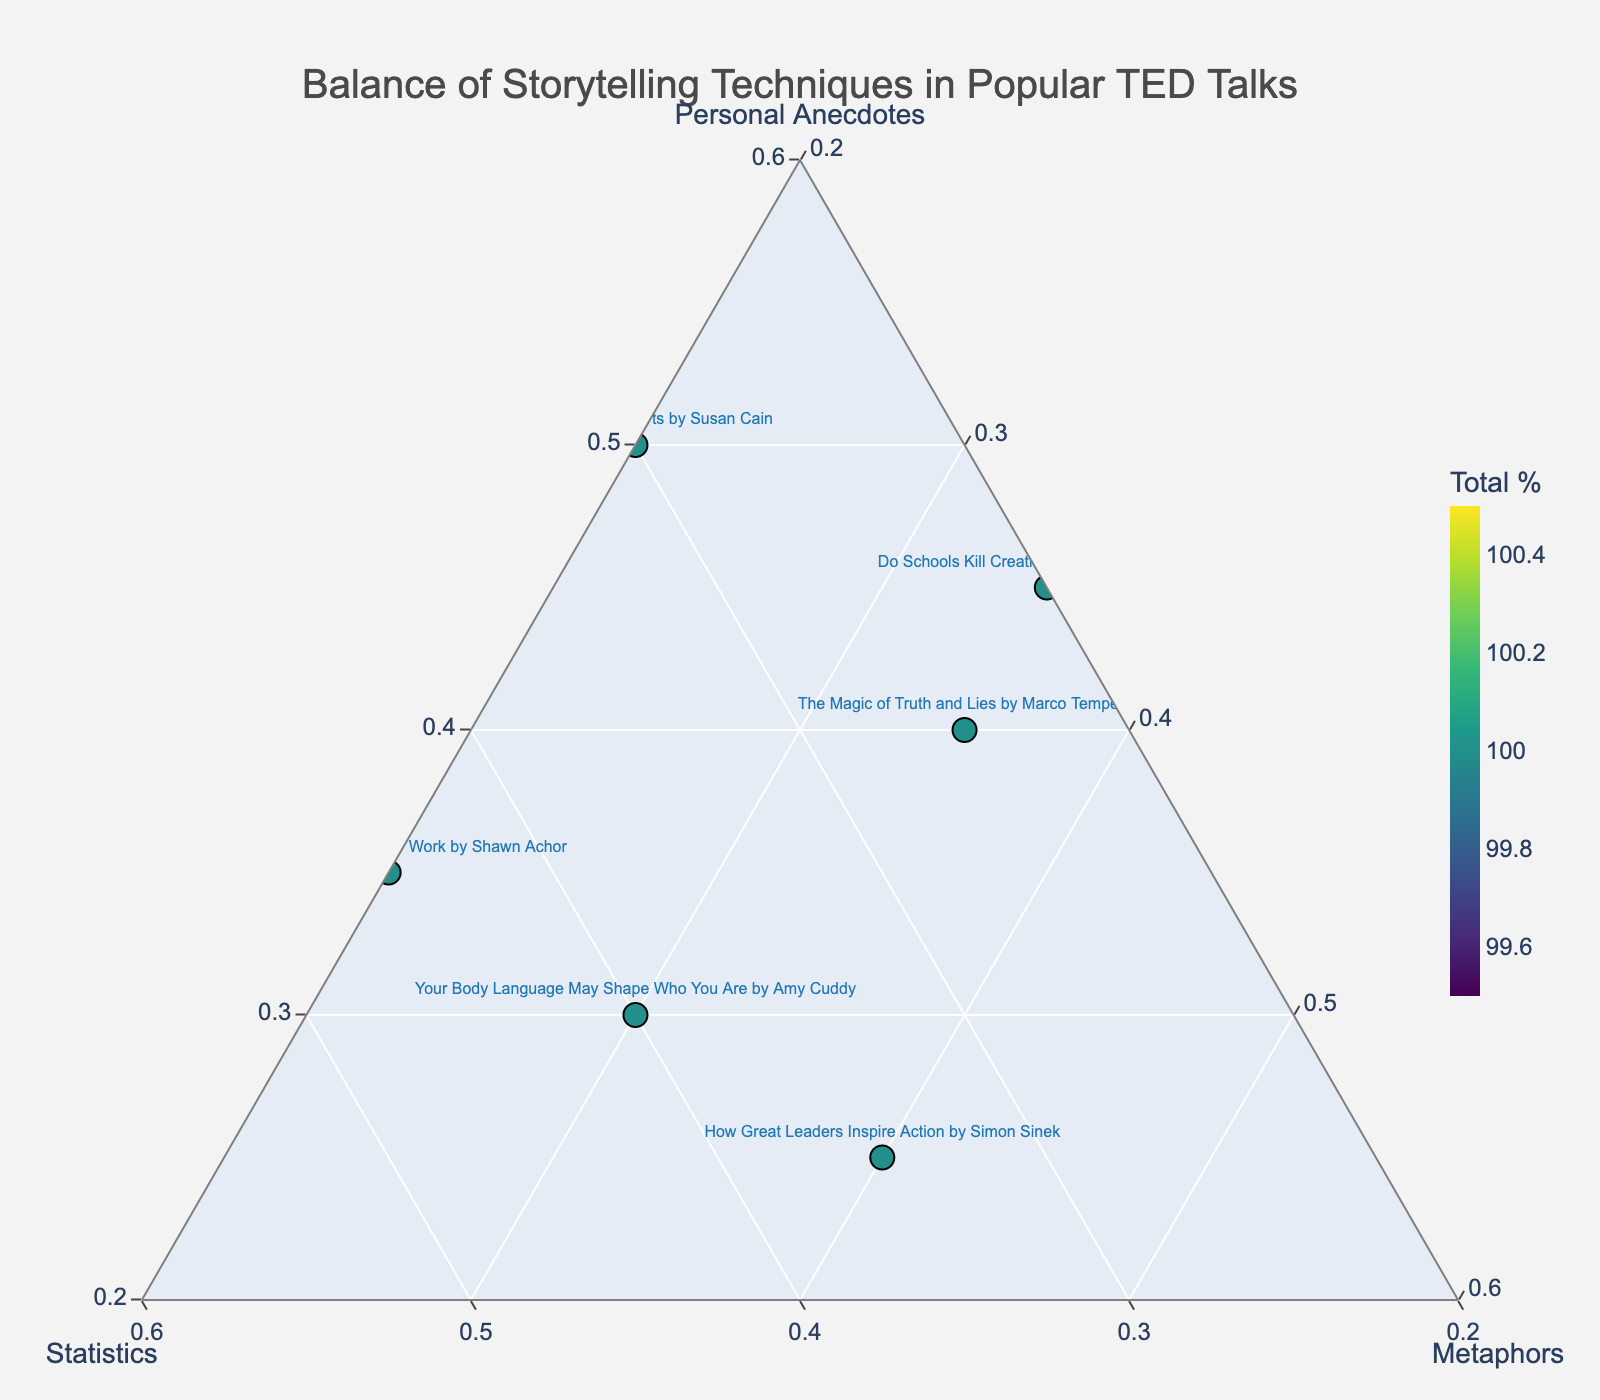Who uses the highest percentage of personal anecdotes? By examining the points positioned towards the vertex labeled 'Personal Anecdotes,' we see that "The Danger of a Single Story" by Chimamanda Ngozi Adichie uses the highest percentage, with 70% personal anecdotes.
Answer: Chimamanda Ngozi Adichie Which TED Talk has the highest total percentage for all storytelling techniques combined? The color intensity of the points in the plot indicates the total percentage of storytelling techniques. "The Danger of a Single Story" by Chimamanda Ngozi Adichie has the highest percentage, 70 + 10 + 20 = 100.
Answer: Chimamanda Ngozi Adichie Which TED Talk has an equal balance of statistics and metaphors? Referring to points where the 'b' and 'c' coordinates are similar, "Do Schools Kill Creativity?" by Sir Ken Robinson and "Your Body Language May Shape Who You Are" by Amy Cuddy show such a balance. Both are close but not exactly equal. From the hovertext, Amy Cuddy's talk has 40% statistics and 30% metaphors.
Answer: Amy Cuddy Which TED Talk is the most balanced in terms of using all three techniques? Points closest to the center of the plot indicate a more balanced use of techniques. It appears that "Your Body Language May Shape Who You Are" by Amy Cuddy has relatively balanced proportions of 30% personal anecdotes, 40% statistics, and 30% metaphors.
Answer: Amy Cuddy Which storytelling technique does "The Power of Introverts" by Susan Cain emphasize the least? Hover over the point representing "The Power of Introverts" to see its proportions. It shows 50% personal anecdotes, 30% statistics, and 20% metaphors, making metaphors the least emphasized.
Answer: Metaphors What is the percentage of statistics in "The Skill of Self-Confidence" by Dr. Ivan Joseph, and how does it compare to the percentage in "The Art of Storytelling" by David JP Phillips? Hovering over these points shows their statistics: "The Skill of Self-Confidence" uses 20% statistics while "The Art of Storytelling" uses 15%. Therefore, Dr. Ivan Joseph's talk uses 5% more statistics.
Answer: 20% vs. 15% Do any TED Talks use an equal percentage of personal anecdotes and metaphors? From the plot, none of the points seem to have 'a' and 'c' coordinates equal. Each talk varies in its composition of personal anecdotes and metaphors without achieving an equal balance.
Answer: No Which TED Talk uses the smallest percentage of statistics, and what is that percentage? Looking towards the vertex labeled 'Statistics' and selecting the point closest to it, "The Danger of a Single Story" by Chimamanda Ngozi Adichie uses only 10% statistics, the smallest percentage among the listed talks.
Answer: 10% What balance strategy is employed in "How Great Leaders Inspire Action" by Simon Sinek? Examine the point for Simon Sinek and its hovertext. The talk has 25% personal anecdotes, 35% statistics, and 40% metaphors, indicating a heavier reliance on metaphors and statistics with fewer personal anecdotes.
Answer: 25% / 35% / 40% Which TED Talk might be easiest to remember for someone who understands concepts through metaphors? Identifying points that show a high proportion of metaphors (near the vertex labeled 'Metaphors'), "How Great Leaders Inspire Action" by Simon Sinek, with 40% metaphors, might be easiest to remember for such a person.
Answer: Simon Sinek 